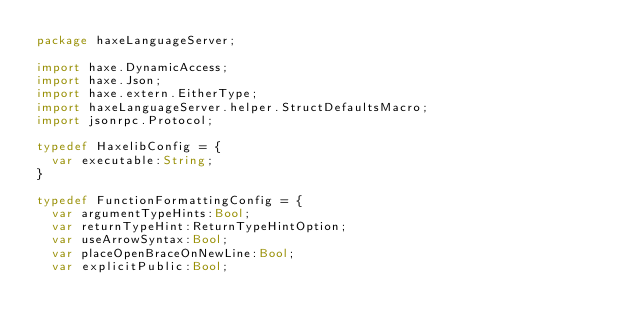Convert code to text. <code><loc_0><loc_0><loc_500><loc_500><_Haxe_>package haxeLanguageServer;

import haxe.DynamicAccess;
import haxe.Json;
import haxe.extern.EitherType;
import haxeLanguageServer.helper.StructDefaultsMacro;
import jsonrpc.Protocol;

typedef HaxelibConfig = {
	var executable:String;
}

typedef FunctionFormattingConfig = {
	var argumentTypeHints:Bool;
	var returnTypeHint:ReturnTypeHintOption;
	var useArrowSyntax:Bool;
	var placeOpenBraceOnNewLine:Bool;
	var explicitPublic:Bool;</code> 